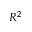<formula> <loc_0><loc_0><loc_500><loc_500>R ^ { 2 }</formula> 